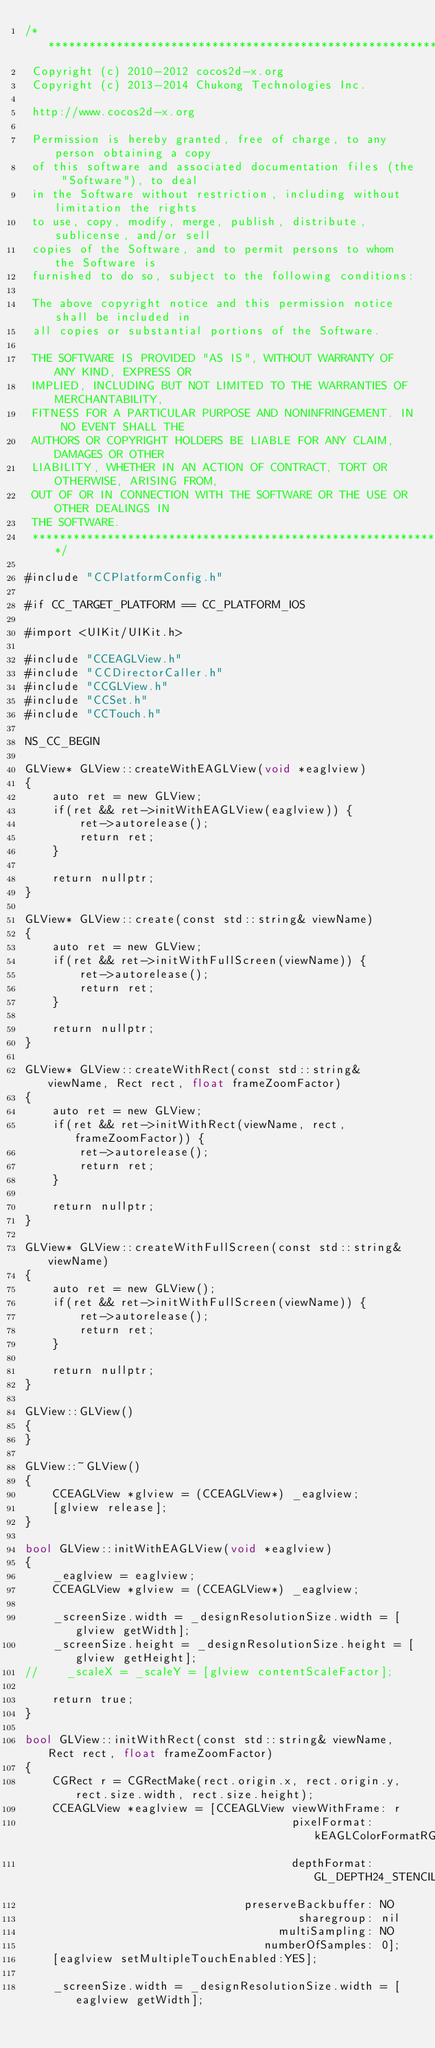<code> <loc_0><loc_0><loc_500><loc_500><_ObjectiveC_>/****************************************************************************
 Copyright (c) 2010-2012 cocos2d-x.org
 Copyright (c) 2013-2014 Chukong Technologies Inc.

 http://www.cocos2d-x.org

 Permission is hereby granted, free of charge, to any person obtaining a copy
 of this software and associated documentation files (the "Software"), to deal
 in the Software without restriction, including without limitation the rights
 to use, copy, modify, merge, publish, distribute, sublicense, and/or sell
 copies of the Software, and to permit persons to whom the Software is
 furnished to do so, subject to the following conditions:

 The above copyright notice and this permission notice shall be included in
 all copies or substantial portions of the Software.

 THE SOFTWARE IS PROVIDED "AS IS", WITHOUT WARRANTY OF ANY KIND, EXPRESS OR
 IMPLIED, INCLUDING BUT NOT LIMITED TO THE WARRANTIES OF MERCHANTABILITY,
 FITNESS FOR A PARTICULAR PURPOSE AND NONINFRINGEMENT. IN NO EVENT SHALL THE
 AUTHORS OR COPYRIGHT HOLDERS BE LIABLE FOR ANY CLAIM, DAMAGES OR OTHER
 LIABILITY, WHETHER IN AN ACTION OF CONTRACT, TORT OR OTHERWISE, ARISING FROM,
 OUT OF OR IN CONNECTION WITH THE SOFTWARE OR THE USE OR OTHER DEALINGS IN
 THE SOFTWARE.
 ****************************************************************************/

#include "CCPlatformConfig.h"

#if CC_TARGET_PLATFORM == CC_PLATFORM_IOS

#import <UIKit/UIKit.h>

#include "CCEAGLView.h"
#include "CCDirectorCaller.h"
#include "CCGLView.h"
#include "CCSet.h"
#include "CCTouch.h"

NS_CC_BEGIN

GLView* GLView::createWithEAGLView(void *eaglview)
{
    auto ret = new GLView;
    if(ret && ret->initWithEAGLView(eaglview)) {
        ret->autorelease();
        return ret;
    }

    return nullptr;
}

GLView* GLView::create(const std::string& viewName)
{
    auto ret = new GLView;
    if(ret && ret->initWithFullScreen(viewName)) {
        ret->autorelease();
        return ret;
    }

    return nullptr;
}

GLView* GLView::createWithRect(const std::string& viewName, Rect rect, float frameZoomFactor)
{
    auto ret = new GLView;
    if(ret && ret->initWithRect(viewName, rect, frameZoomFactor)) {
        ret->autorelease();
        return ret;
    }

    return nullptr;
}

GLView* GLView::createWithFullScreen(const std::string& viewName)
{
    auto ret = new GLView();
    if(ret && ret->initWithFullScreen(viewName)) {
        ret->autorelease();
        return ret;
    }

    return nullptr;
}

GLView::GLView()
{
}

GLView::~GLView()
{
    CCEAGLView *glview = (CCEAGLView*) _eaglview;
    [glview release];
}

bool GLView::initWithEAGLView(void *eaglview)
{
    _eaglview = eaglview;
    CCEAGLView *glview = (CCEAGLView*) _eaglview;

    _screenSize.width = _designResolutionSize.width = [glview getWidth];
    _screenSize.height = _designResolutionSize.height = [glview getHeight];
//    _scaleX = _scaleY = [glview contentScaleFactor];

    return true;
}

bool GLView::initWithRect(const std::string& viewName, Rect rect, float frameZoomFactor)
{
    CGRect r = CGRectMake(rect.origin.x, rect.origin.y, rect.size.width, rect.size.height);
    CCEAGLView *eaglview = [CCEAGLView viewWithFrame: r
                                       pixelFormat: kEAGLColorFormatRGB565
                                       depthFormat: GL_DEPTH24_STENCIL8_OES
                                preserveBackbuffer: NO
                                        sharegroup: nil
                                     multiSampling: NO
                                   numberOfSamples: 0];
    [eaglview setMultipleTouchEnabled:YES];

    _screenSize.width = _designResolutionSize.width = [eaglview getWidth];</code> 